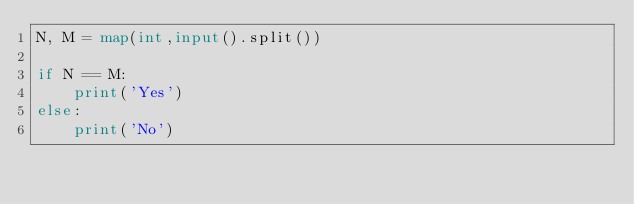<code> <loc_0><loc_0><loc_500><loc_500><_Python_>N, M = map(int,input().split())

if N == M:
    print('Yes')
else:
    print('No')</code> 